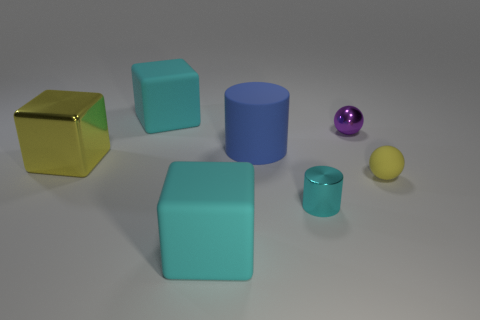Add 1 big objects. How many objects exist? 8 Subtract all cubes. How many objects are left? 4 Add 7 cyan rubber cubes. How many cyan rubber cubes exist? 9 Subtract 1 blue cylinders. How many objects are left? 6 Subtract all tiny cyan cylinders. Subtract all big brown things. How many objects are left? 6 Add 3 small cyan things. How many small cyan things are left? 4 